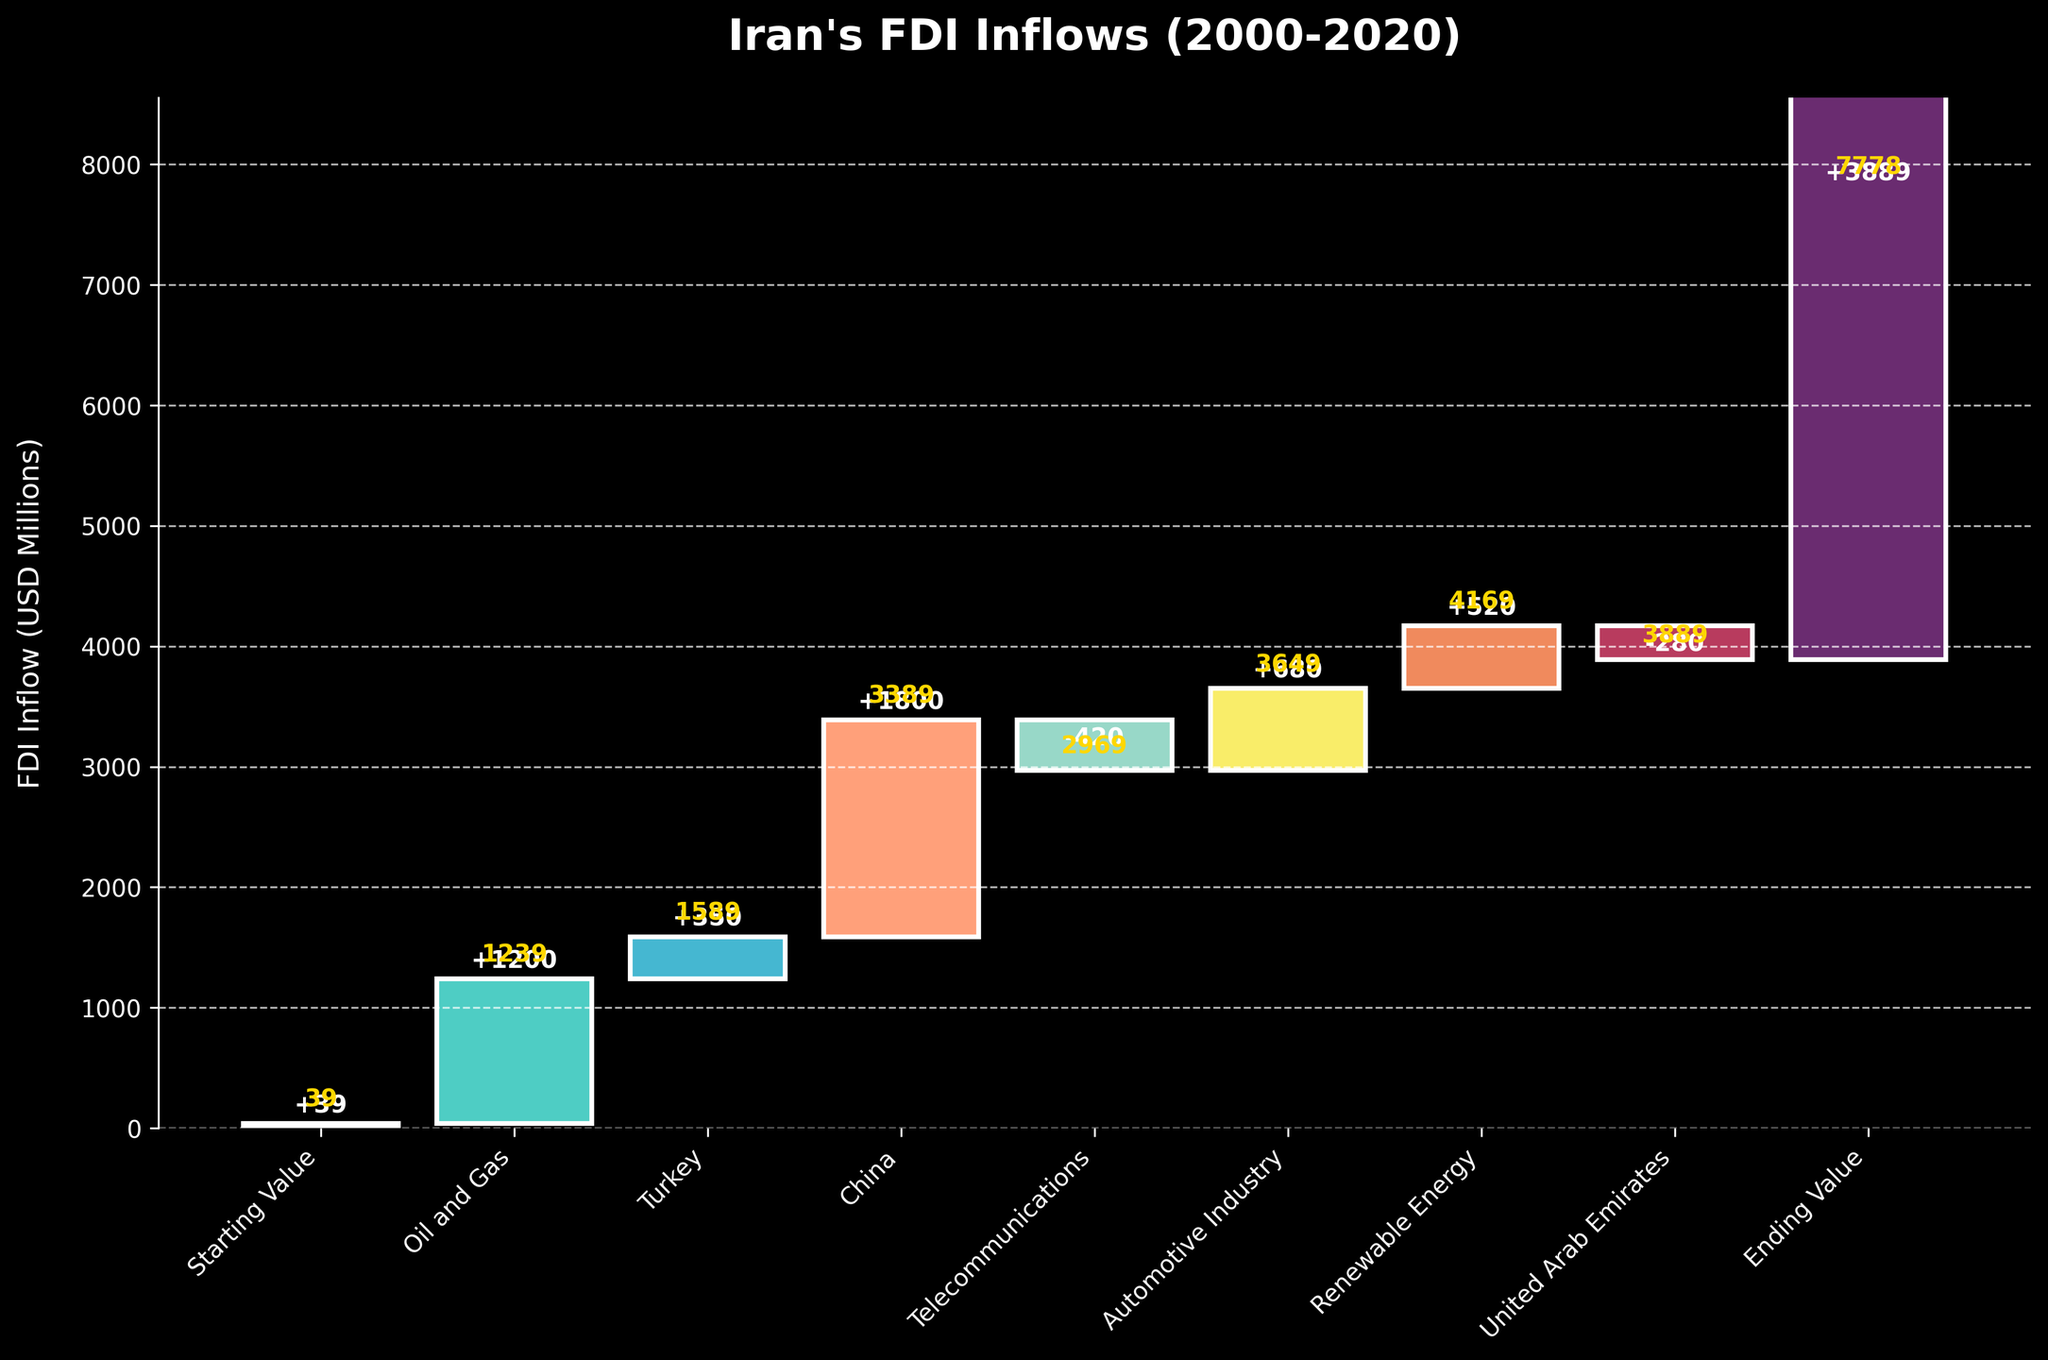What is the title of the chart? The title of the chart is displayed at the top of the figure. It summarizes the content and context of the chart.
Answer: Iran's FDI Inflows (2000-2020) How much foreign direct investment was there in the Oil and Gas sector in 2005? The FDI inflow for each category and year is labeled on the chart. For the Oil and Gas sector in 2005, the label is +1200.
Answer: 1200 Which sector had a negative FDI inflow, and what was the value? The negative values could be identified by the downward bars in the chart, and their labels are mentioned on the respective bars. The sectors with negative FDI inflows have values below the starting point.
Answer: Telecommunications, -420 What was the cumulative FDI inflow by the year 2018? The cumulative value by any year can be read from the cumulative bar labels above the specific year segments. For 2018, the label shows 4169.
Answer: 4169 Between China in 2012 and the United Arab Emirates in 2019, which one had a higher FDI inflow and by how much? By comparing the two segment labels, China in 2012 had +1800, while the United Arab Emirates in 2019 had -280. Subtracting these values provides the difference.
Answer: China by 2080 What is the final FDI value in 2020? The cumulative value in 2020, labeled at the top of the final bar, indicates the ending value of FDI in 2020.
Answer: 3889 What is the total FDI inflow from Turkey and the Automotive Industry combined? By summing the values labeled for Turkey in 2010 (+350) and the Automotive Industry in 2016 (+680), the combined total can be calculated.
Answer: 1030 How does the FDI inflow in Renewable Energy compare to that of the Automotive Industry? Comparing the labeled values for these sectors, the Renewable Energy in 2018 has +520, and the Automotive Industry in 2016 has +680. Thus, the Automotive Industry has higher FDI.
Answer: Automotive Industry has higher by 160 What was the change in FDI inflow from the Starting Value to the Ending Value? Subtracting the starting value (39) from the ending value (3889) will give the total change over the period.
Answer: 3850 